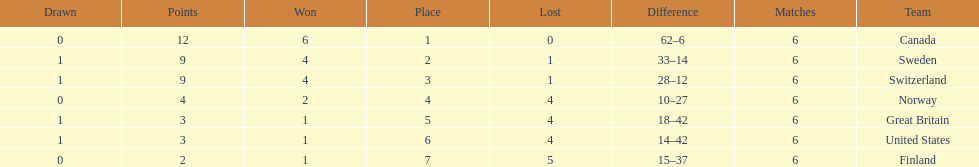How many teams won at least 2 games throughout the 1951 world ice hockey championships? 4. 